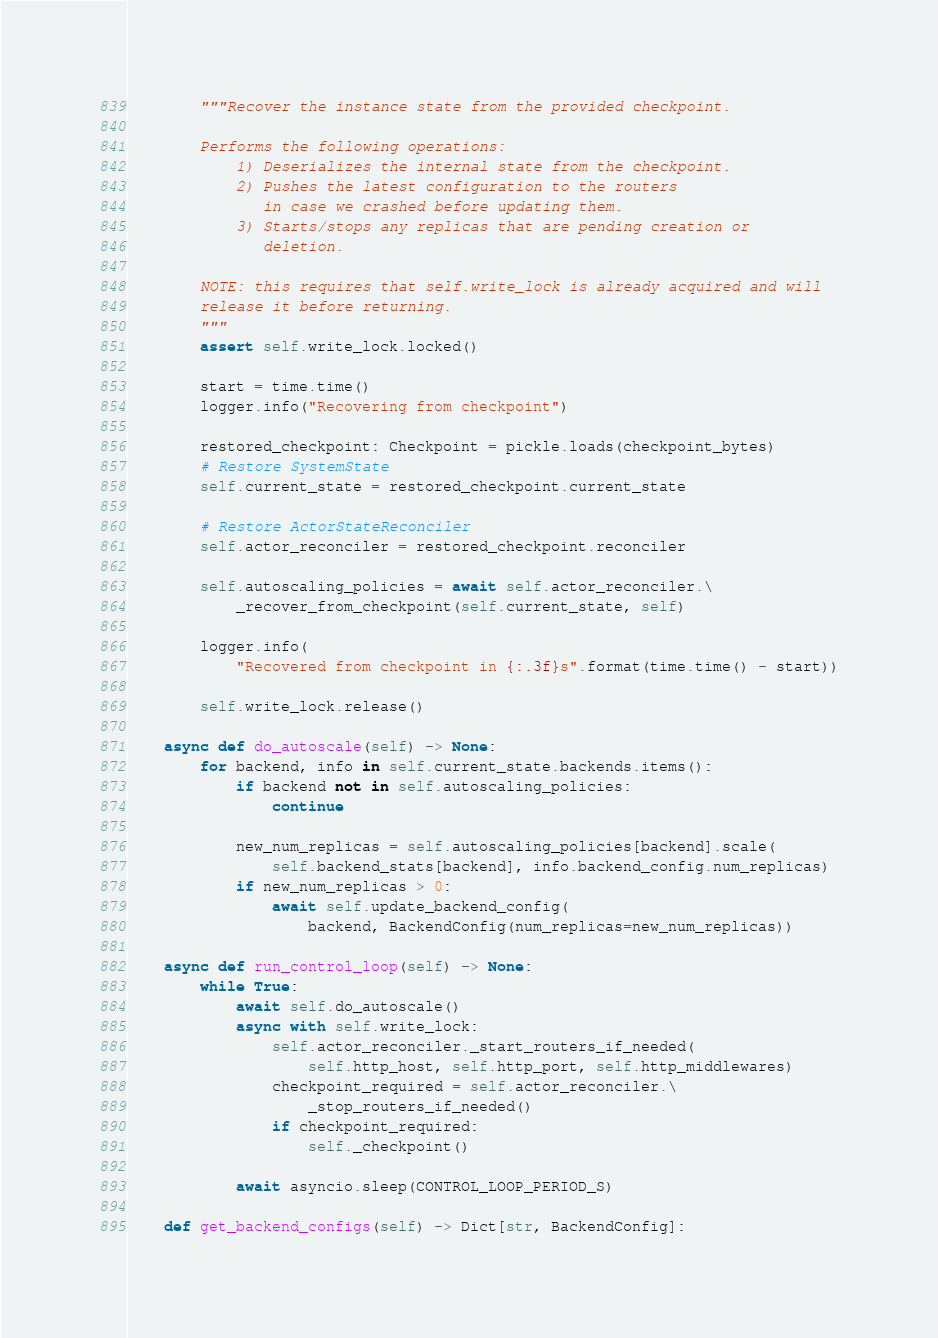Convert code to text. <code><loc_0><loc_0><loc_500><loc_500><_Python_>        """Recover the instance state from the provided checkpoint.

        Performs the following operations:
            1) Deserializes the internal state from the checkpoint.
            2) Pushes the latest configuration to the routers
               in case we crashed before updating them.
            3) Starts/stops any replicas that are pending creation or
               deletion.

        NOTE: this requires that self.write_lock is already acquired and will
        release it before returning.
        """
        assert self.write_lock.locked()

        start = time.time()
        logger.info("Recovering from checkpoint")

        restored_checkpoint: Checkpoint = pickle.loads(checkpoint_bytes)
        # Restore SystemState
        self.current_state = restored_checkpoint.current_state

        # Restore ActorStateReconciler
        self.actor_reconciler = restored_checkpoint.reconciler

        self.autoscaling_policies = await self.actor_reconciler.\
            _recover_from_checkpoint(self.current_state, self)

        logger.info(
            "Recovered from checkpoint in {:.3f}s".format(time.time() - start))

        self.write_lock.release()

    async def do_autoscale(self) -> None:
        for backend, info in self.current_state.backends.items():
            if backend not in self.autoscaling_policies:
                continue

            new_num_replicas = self.autoscaling_policies[backend].scale(
                self.backend_stats[backend], info.backend_config.num_replicas)
            if new_num_replicas > 0:
                await self.update_backend_config(
                    backend, BackendConfig(num_replicas=new_num_replicas))

    async def run_control_loop(self) -> None:
        while True:
            await self.do_autoscale()
            async with self.write_lock:
                self.actor_reconciler._start_routers_if_needed(
                    self.http_host, self.http_port, self.http_middlewares)
                checkpoint_required = self.actor_reconciler.\
                    _stop_routers_if_needed()
                if checkpoint_required:
                    self._checkpoint()

            await asyncio.sleep(CONTROL_LOOP_PERIOD_S)

    def get_backend_configs(self) -> Dict[str, BackendConfig]:</code> 